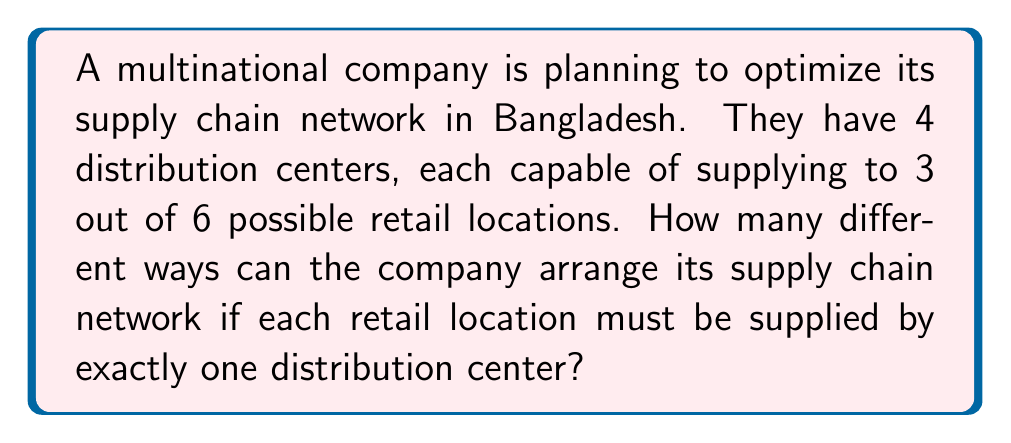What is the answer to this math problem? Let's approach this step-by-step:

1) First, we need to understand what we're counting. We're essentially assigning each of the 6 retail locations to one of the 4 distribution centers that can supply it.

2) For each retail location, we have 3 choices (since each distribution center can supply to 3 out of 6 locations).

3) This scenario can be modeled using the multiplication principle. For each independent choice, we multiply the number of options.

4) Therefore, the total number of ways to arrange the supply chain is:

   $$ 3 \times 3 \times 3 \times 3 \times 3 \times 3 = 3^6 $$

5) This is because we have 6 independent choices (one for each retail location), and each choice has 3 options.

6) Calculating this:

   $$ 3^6 = 3 \times 3 \times 3 \times 3 \times 3 \times 3 = 729 $$

Thus, there are 729 different ways the company can arrange its supply chain network under these conditions.
Answer: 729 